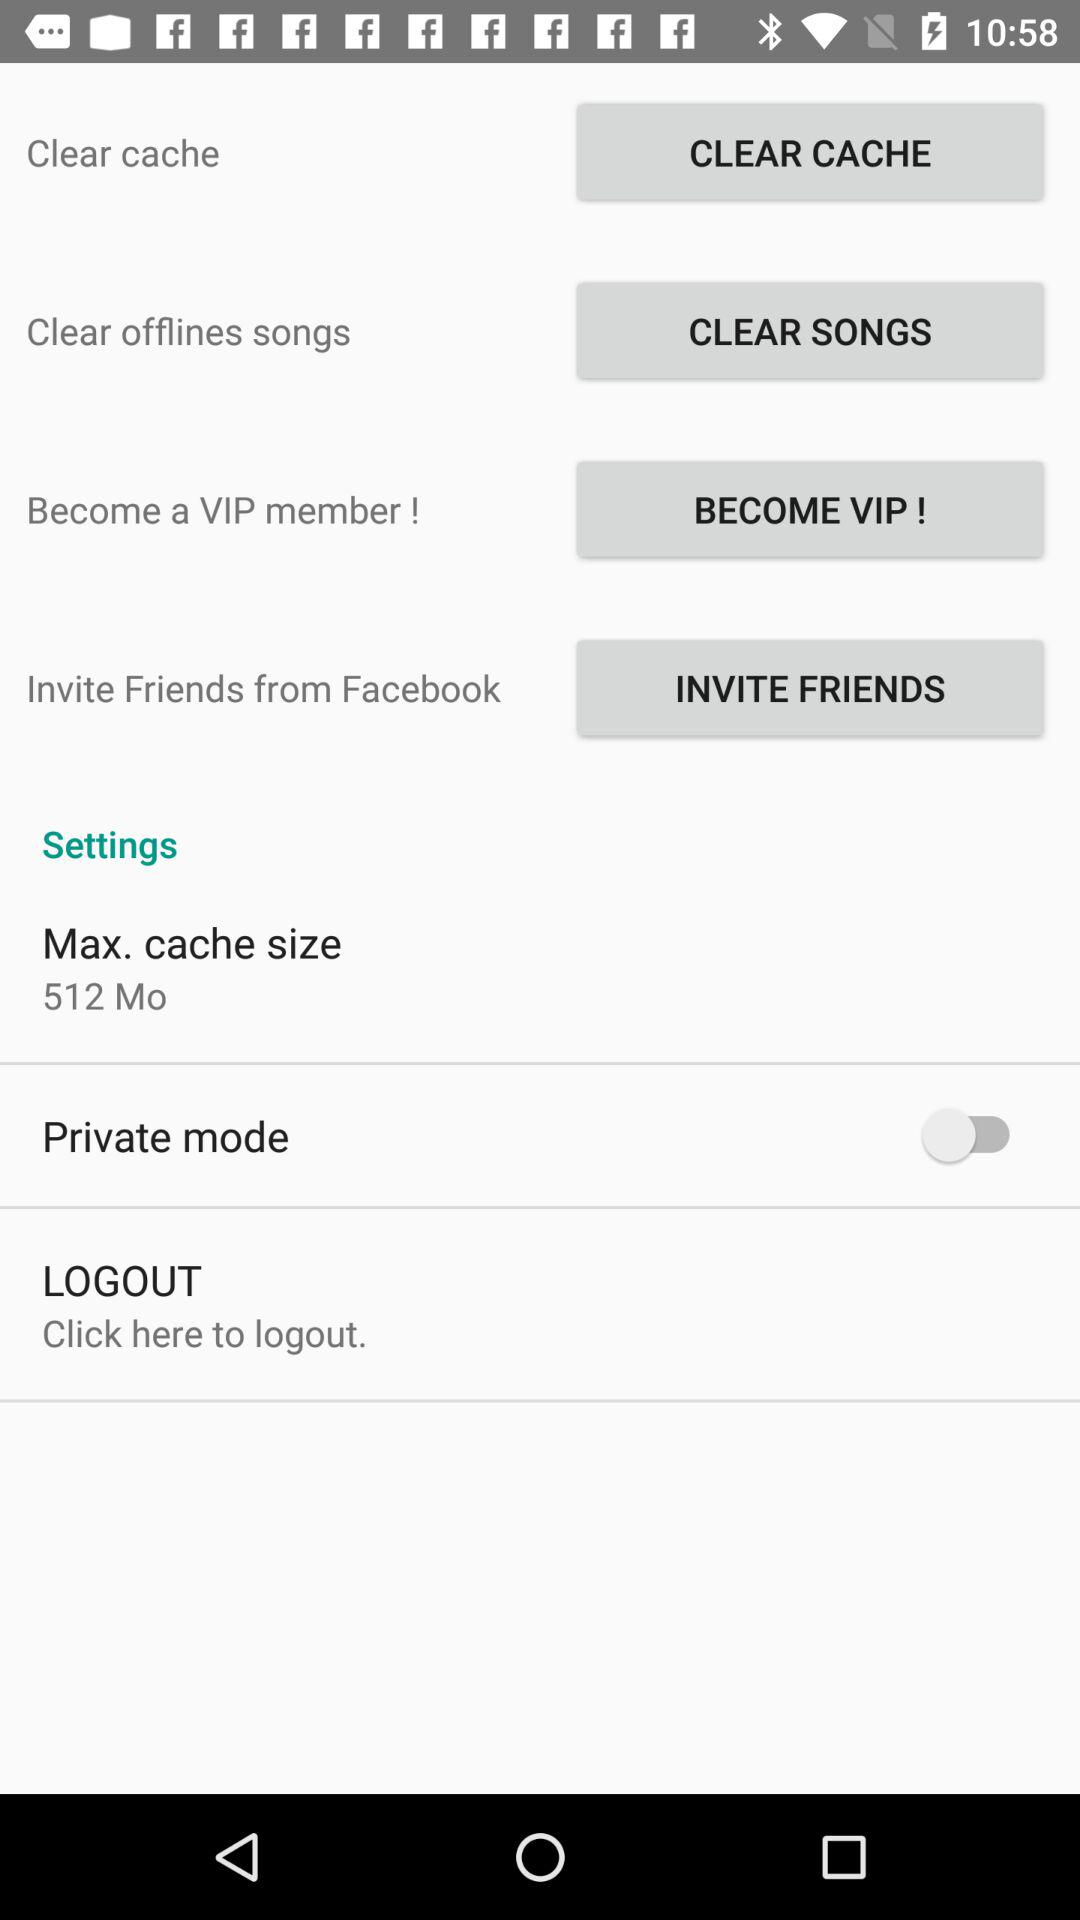What is the status of "Private mode"? The status is "off". 